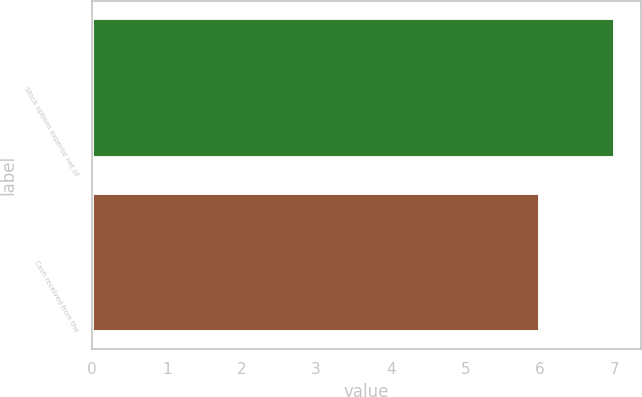Convert chart to OTSL. <chart><loc_0><loc_0><loc_500><loc_500><bar_chart><fcel>Stock options expense net of<fcel>Cash received from the<nl><fcel>7<fcel>6<nl></chart> 